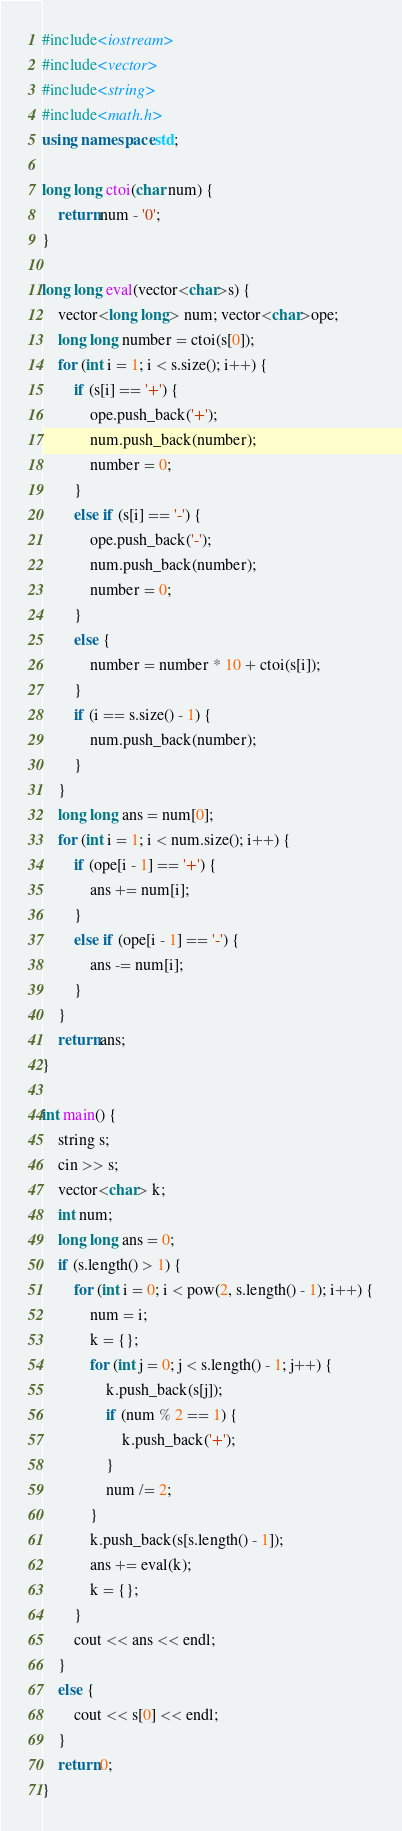<code> <loc_0><loc_0><loc_500><loc_500><_C++_>#include<iostream>
#include<vector>
#include<string>
#include<math.h>
using namespace std;

long long ctoi(char num) {
	return num - '0';
}

long long eval(vector<char>s) {
	vector<long long> num; vector<char>ope;
	long long number = ctoi(s[0]);
	for (int i = 1; i < s.size(); i++) {
		if (s[i] == '+') {
			ope.push_back('+');
			num.push_back(number);
			number = 0;
		}
		else if (s[i] == '-') {
			ope.push_back('-');
			num.push_back(number);
			number = 0;
		}
		else {
			number = number * 10 + ctoi(s[i]);
		}
		if (i == s.size() - 1) {
			num.push_back(number);
		}
	}
	long long ans = num[0];
	for (int i = 1; i < num.size(); i++) {
		if (ope[i - 1] == '+') {
			ans += num[i];
		}
		else if (ope[i - 1] == '-') {
			ans -= num[i];
		}
	}
	return ans;
}

int main() {
	string s;
	cin >> s;
	vector<char> k;
	int num;
	long long ans = 0;
	if (s.length() > 1) {
		for (int i = 0; i < pow(2, s.length() - 1); i++) {
			num = i;
			k = {};
			for (int j = 0; j < s.length() - 1; j++) {
				k.push_back(s[j]);
				if (num % 2 == 1) {
					k.push_back('+');
				}
				num /= 2;
			}
			k.push_back(s[s.length() - 1]);
			ans += eval(k);
			k = {};
		}
		cout << ans << endl;
	}
	else {
		cout << s[0] << endl;
	}
	return 0;
}</code> 